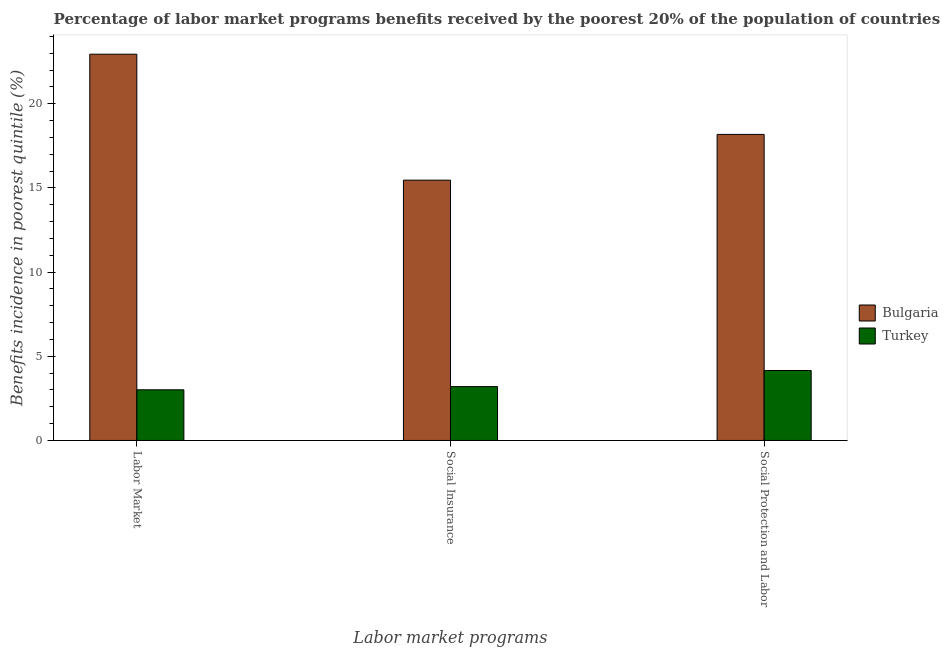How many different coloured bars are there?
Your answer should be very brief. 2. Are the number of bars per tick equal to the number of legend labels?
Provide a succinct answer. Yes. How many bars are there on the 3rd tick from the left?
Keep it short and to the point. 2. How many bars are there on the 1st tick from the right?
Your answer should be very brief. 2. What is the label of the 2nd group of bars from the left?
Offer a very short reply. Social Insurance. What is the percentage of benefits received due to social insurance programs in Bulgaria?
Ensure brevity in your answer.  15.46. Across all countries, what is the maximum percentage of benefits received due to labor market programs?
Ensure brevity in your answer.  22.94. Across all countries, what is the minimum percentage of benefits received due to social protection programs?
Provide a succinct answer. 4.15. In which country was the percentage of benefits received due to social insurance programs maximum?
Your response must be concise. Bulgaria. In which country was the percentage of benefits received due to labor market programs minimum?
Ensure brevity in your answer.  Turkey. What is the total percentage of benefits received due to labor market programs in the graph?
Provide a succinct answer. 25.95. What is the difference between the percentage of benefits received due to labor market programs in Bulgaria and that in Turkey?
Make the answer very short. 19.93. What is the difference between the percentage of benefits received due to social protection programs in Turkey and the percentage of benefits received due to social insurance programs in Bulgaria?
Ensure brevity in your answer.  -11.31. What is the average percentage of benefits received due to social protection programs per country?
Make the answer very short. 11.17. What is the difference between the percentage of benefits received due to social insurance programs and percentage of benefits received due to social protection programs in Bulgaria?
Ensure brevity in your answer.  -2.72. In how many countries, is the percentage of benefits received due to labor market programs greater than 7 %?
Make the answer very short. 1. What is the ratio of the percentage of benefits received due to social insurance programs in Bulgaria to that in Turkey?
Your response must be concise. 4.83. Is the difference between the percentage of benefits received due to labor market programs in Turkey and Bulgaria greater than the difference between the percentage of benefits received due to social protection programs in Turkey and Bulgaria?
Ensure brevity in your answer.  No. What is the difference between the highest and the second highest percentage of benefits received due to labor market programs?
Make the answer very short. 19.93. What is the difference between the highest and the lowest percentage of benefits received due to labor market programs?
Provide a short and direct response. 19.93. In how many countries, is the percentage of benefits received due to social insurance programs greater than the average percentage of benefits received due to social insurance programs taken over all countries?
Ensure brevity in your answer.  1. Is the sum of the percentage of benefits received due to social protection programs in Turkey and Bulgaria greater than the maximum percentage of benefits received due to labor market programs across all countries?
Give a very brief answer. No. What does the 1st bar from the right in Labor Market represents?
Keep it short and to the point. Turkey. Are all the bars in the graph horizontal?
Provide a short and direct response. No. Are the values on the major ticks of Y-axis written in scientific E-notation?
Keep it short and to the point. No. Does the graph contain grids?
Offer a very short reply. No. Where does the legend appear in the graph?
Ensure brevity in your answer.  Center right. How many legend labels are there?
Give a very brief answer. 2. What is the title of the graph?
Provide a short and direct response. Percentage of labor market programs benefits received by the poorest 20% of the population of countries. Does "Luxembourg" appear as one of the legend labels in the graph?
Provide a short and direct response. No. What is the label or title of the X-axis?
Your answer should be compact. Labor market programs. What is the label or title of the Y-axis?
Provide a short and direct response. Benefits incidence in poorest quintile (%). What is the Benefits incidence in poorest quintile (%) in Bulgaria in Labor Market?
Your response must be concise. 22.94. What is the Benefits incidence in poorest quintile (%) of Turkey in Labor Market?
Give a very brief answer. 3.01. What is the Benefits incidence in poorest quintile (%) of Bulgaria in Social Insurance?
Give a very brief answer. 15.46. What is the Benefits incidence in poorest quintile (%) in Turkey in Social Insurance?
Make the answer very short. 3.2. What is the Benefits incidence in poorest quintile (%) of Bulgaria in Social Protection and Labor?
Offer a terse response. 18.18. What is the Benefits incidence in poorest quintile (%) of Turkey in Social Protection and Labor?
Your answer should be compact. 4.15. Across all Labor market programs, what is the maximum Benefits incidence in poorest quintile (%) in Bulgaria?
Ensure brevity in your answer.  22.94. Across all Labor market programs, what is the maximum Benefits incidence in poorest quintile (%) of Turkey?
Offer a terse response. 4.15. Across all Labor market programs, what is the minimum Benefits incidence in poorest quintile (%) of Bulgaria?
Your answer should be very brief. 15.46. Across all Labor market programs, what is the minimum Benefits incidence in poorest quintile (%) of Turkey?
Your answer should be very brief. 3.01. What is the total Benefits incidence in poorest quintile (%) of Bulgaria in the graph?
Your answer should be very brief. 56.58. What is the total Benefits incidence in poorest quintile (%) in Turkey in the graph?
Your answer should be very brief. 10.36. What is the difference between the Benefits incidence in poorest quintile (%) in Bulgaria in Labor Market and that in Social Insurance?
Your response must be concise. 7.48. What is the difference between the Benefits incidence in poorest quintile (%) of Turkey in Labor Market and that in Social Insurance?
Keep it short and to the point. -0.19. What is the difference between the Benefits incidence in poorest quintile (%) of Bulgaria in Labor Market and that in Social Protection and Labor?
Your answer should be very brief. 4.76. What is the difference between the Benefits incidence in poorest quintile (%) of Turkey in Labor Market and that in Social Protection and Labor?
Provide a succinct answer. -1.15. What is the difference between the Benefits incidence in poorest quintile (%) of Bulgaria in Social Insurance and that in Social Protection and Labor?
Provide a succinct answer. -2.72. What is the difference between the Benefits incidence in poorest quintile (%) of Turkey in Social Insurance and that in Social Protection and Labor?
Keep it short and to the point. -0.96. What is the difference between the Benefits incidence in poorest quintile (%) of Bulgaria in Labor Market and the Benefits incidence in poorest quintile (%) of Turkey in Social Insurance?
Ensure brevity in your answer.  19.74. What is the difference between the Benefits incidence in poorest quintile (%) of Bulgaria in Labor Market and the Benefits incidence in poorest quintile (%) of Turkey in Social Protection and Labor?
Keep it short and to the point. 18.79. What is the difference between the Benefits incidence in poorest quintile (%) in Bulgaria in Social Insurance and the Benefits incidence in poorest quintile (%) in Turkey in Social Protection and Labor?
Keep it short and to the point. 11.31. What is the average Benefits incidence in poorest quintile (%) of Bulgaria per Labor market programs?
Your response must be concise. 18.86. What is the average Benefits incidence in poorest quintile (%) in Turkey per Labor market programs?
Your answer should be compact. 3.45. What is the difference between the Benefits incidence in poorest quintile (%) in Bulgaria and Benefits incidence in poorest quintile (%) in Turkey in Labor Market?
Your response must be concise. 19.93. What is the difference between the Benefits incidence in poorest quintile (%) of Bulgaria and Benefits incidence in poorest quintile (%) of Turkey in Social Insurance?
Make the answer very short. 12.26. What is the difference between the Benefits incidence in poorest quintile (%) of Bulgaria and Benefits incidence in poorest quintile (%) of Turkey in Social Protection and Labor?
Your answer should be compact. 14.02. What is the ratio of the Benefits incidence in poorest quintile (%) in Bulgaria in Labor Market to that in Social Insurance?
Your answer should be compact. 1.48. What is the ratio of the Benefits incidence in poorest quintile (%) in Turkey in Labor Market to that in Social Insurance?
Offer a very short reply. 0.94. What is the ratio of the Benefits incidence in poorest quintile (%) of Bulgaria in Labor Market to that in Social Protection and Labor?
Make the answer very short. 1.26. What is the ratio of the Benefits incidence in poorest quintile (%) in Turkey in Labor Market to that in Social Protection and Labor?
Give a very brief answer. 0.72. What is the ratio of the Benefits incidence in poorest quintile (%) in Bulgaria in Social Insurance to that in Social Protection and Labor?
Provide a short and direct response. 0.85. What is the ratio of the Benefits incidence in poorest quintile (%) of Turkey in Social Insurance to that in Social Protection and Labor?
Your answer should be very brief. 0.77. What is the difference between the highest and the second highest Benefits incidence in poorest quintile (%) of Bulgaria?
Keep it short and to the point. 4.76. What is the difference between the highest and the second highest Benefits incidence in poorest quintile (%) of Turkey?
Provide a short and direct response. 0.96. What is the difference between the highest and the lowest Benefits incidence in poorest quintile (%) in Bulgaria?
Provide a succinct answer. 7.48. What is the difference between the highest and the lowest Benefits incidence in poorest quintile (%) in Turkey?
Make the answer very short. 1.15. 